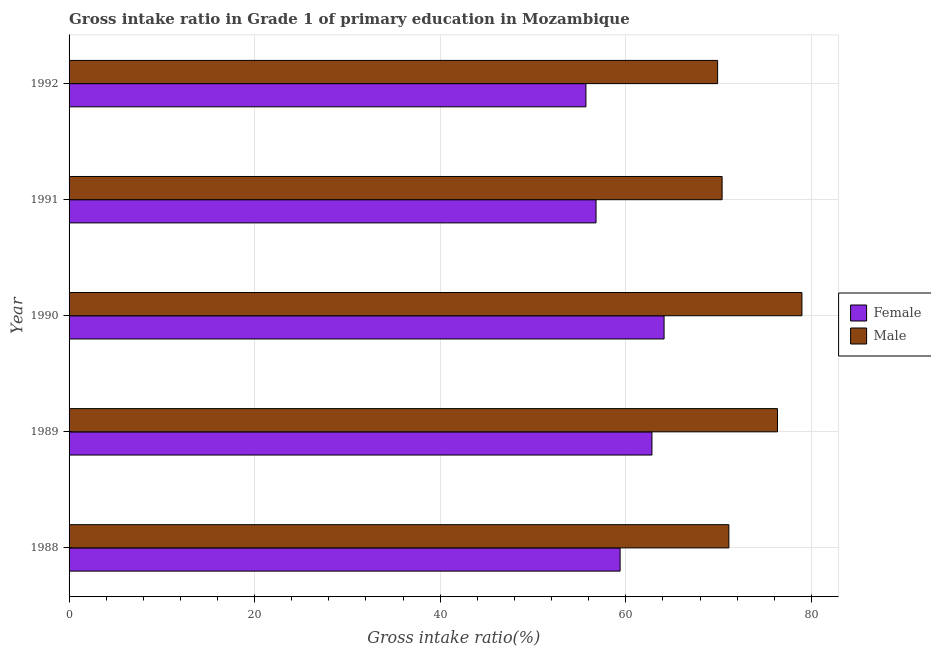How many different coloured bars are there?
Keep it short and to the point. 2. Are the number of bars per tick equal to the number of legend labels?
Ensure brevity in your answer.  Yes. How many bars are there on the 2nd tick from the top?
Provide a short and direct response. 2. What is the label of the 4th group of bars from the top?
Ensure brevity in your answer.  1989. In how many cases, is the number of bars for a given year not equal to the number of legend labels?
Make the answer very short. 0. What is the gross intake ratio(female) in 1989?
Ensure brevity in your answer.  62.82. Across all years, what is the maximum gross intake ratio(male)?
Keep it short and to the point. 78.98. Across all years, what is the minimum gross intake ratio(female)?
Give a very brief answer. 55.7. In which year was the gross intake ratio(male) maximum?
Give a very brief answer. 1990. What is the total gross intake ratio(female) in the graph?
Ensure brevity in your answer.  298.83. What is the difference between the gross intake ratio(female) in 1988 and that in 1990?
Keep it short and to the point. -4.74. What is the difference between the gross intake ratio(female) in 1989 and the gross intake ratio(male) in 1991?
Your answer should be very brief. -7.56. What is the average gross intake ratio(male) per year?
Make the answer very short. 73.34. In the year 1991, what is the difference between the gross intake ratio(male) and gross intake ratio(female)?
Offer a very short reply. 13.59. What is the ratio of the gross intake ratio(male) in 1990 to that in 1992?
Keep it short and to the point. 1.13. Is the gross intake ratio(male) in 1989 less than that in 1990?
Give a very brief answer. Yes. What is the difference between the highest and the second highest gross intake ratio(male)?
Your response must be concise. 2.63. What is the difference between the highest and the lowest gross intake ratio(male)?
Provide a short and direct response. 9.09. How many bars are there?
Your answer should be very brief. 10. Are all the bars in the graph horizontal?
Make the answer very short. Yes. What is the difference between two consecutive major ticks on the X-axis?
Your answer should be compact. 20. Are the values on the major ticks of X-axis written in scientific E-notation?
Make the answer very short. No. Does the graph contain any zero values?
Your answer should be compact. No. Does the graph contain grids?
Keep it short and to the point. Yes. How are the legend labels stacked?
Your response must be concise. Vertical. What is the title of the graph?
Your answer should be compact. Gross intake ratio in Grade 1 of primary education in Mozambique. Does "Private credit bureau" appear as one of the legend labels in the graph?
Your response must be concise. No. What is the label or title of the X-axis?
Give a very brief answer. Gross intake ratio(%). What is the label or title of the Y-axis?
Provide a short and direct response. Year. What is the Gross intake ratio(%) in Female in 1988?
Ensure brevity in your answer.  59.39. What is the Gross intake ratio(%) in Male in 1988?
Your answer should be compact. 71.11. What is the Gross intake ratio(%) of Female in 1989?
Provide a succinct answer. 62.82. What is the Gross intake ratio(%) of Male in 1989?
Give a very brief answer. 76.35. What is the Gross intake ratio(%) in Female in 1990?
Offer a terse response. 64.13. What is the Gross intake ratio(%) in Male in 1990?
Your answer should be compact. 78.98. What is the Gross intake ratio(%) of Female in 1991?
Ensure brevity in your answer.  56.79. What is the Gross intake ratio(%) in Male in 1991?
Keep it short and to the point. 70.38. What is the Gross intake ratio(%) in Female in 1992?
Provide a succinct answer. 55.7. What is the Gross intake ratio(%) in Male in 1992?
Your answer should be very brief. 69.9. Across all years, what is the maximum Gross intake ratio(%) of Female?
Your answer should be very brief. 64.13. Across all years, what is the maximum Gross intake ratio(%) in Male?
Offer a terse response. 78.98. Across all years, what is the minimum Gross intake ratio(%) in Female?
Your answer should be compact. 55.7. Across all years, what is the minimum Gross intake ratio(%) of Male?
Keep it short and to the point. 69.9. What is the total Gross intake ratio(%) of Female in the graph?
Your answer should be very brief. 298.83. What is the total Gross intake ratio(%) in Male in the graph?
Give a very brief answer. 366.72. What is the difference between the Gross intake ratio(%) in Female in 1988 and that in 1989?
Your answer should be very brief. -3.43. What is the difference between the Gross intake ratio(%) in Male in 1988 and that in 1989?
Keep it short and to the point. -5.24. What is the difference between the Gross intake ratio(%) in Female in 1988 and that in 1990?
Keep it short and to the point. -4.74. What is the difference between the Gross intake ratio(%) in Male in 1988 and that in 1990?
Keep it short and to the point. -7.88. What is the difference between the Gross intake ratio(%) of Female in 1988 and that in 1991?
Ensure brevity in your answer.  2.59. What is the difference between the Gross intake ratio(%) of Male in 1988 and that in 1991?
Make the answer very short. 0.73. What is the difference between the Gross intake ratio(%) in Female in 1988 and that in 1992?
Your answer should be compact. 3.68. What is the difference between the Gross intake ratio(%) in Male in 1988 and that in 1992?
Give a very brief answer. 1.21. What is the difference between the Gross intake ratio(%) of Female in 1989 and that in 1990?
Offer a very short reply. -1.31. What is the difference between the Gross intake ratio(%) in Male in 1989 and that in 1990?
Make the answer very short. -2.63. What is the difference between the Gross intake ratio(%) in Female in 1989 and that in 1991?
Provide a short and direct response. 6.03. What is the difference between the Gross intake ratio(%) of Male in 1989 and that in 1991?
Provide a short and direct response. 5.97. What is the difference between the Gross intake ratio(%) of Female in 1989 and that in 1992?
Ensure brevity in your answer.  7.12. What is the difference between the Gross intake ratio(%) in Male in 1989 and that in 1992?
Your answer should be compact. 6.45. What is the difference between the Gross intake ratio(%) of Female in 1990 and that in 1991?
Offer a terse response. 7.33. What is the difference between the Gross intake ratio(%) of Male in 1990 and that in 1991?
Keep it short and to the point. 8.6. What is the difference between the Gross intake ratio(%) of Female in 1990 and that in 1992?
Provide a succinct answer. 8.42. What is the difference between the Gross intake ratio(%) in Male in 1990 and that in 1992?
Your answer should be compact. 9.09. What is the difference between the Gross intake ratio(%) of Female in 1991 and that in 1992?
Your answer should be very brief. 1.09. What is the difference between the Gross intake ratio(%) in Male in 1991 and that in 1992?
Make the answer very short. 0.48. What is the difference between the Gross intake ratio(%) of Female in 1988 and the Gross intake ratio(%) of Male in 1989?
Make the answer very short. -16.96. What is the difference between the Gross intake ratio(%) in Female in 1988 and the Gross intake ratio(%) in Male in 1990?
Your answer should be compact. -19.6. What is the difference between the Gross intake ratio(%) of Female in 1988 and the Gross intake ratio(%) of Male in 1991?
Your answer should be compact. -10.99. What is the difference between the Gross intake ratio(%) in Female in 1988 and the Gross intake ratio(%) in Male in 1992?
Offer a very short reply. -10.51. What is the difference between the Gross intake ratio(%) in Female in 1989 and the Gross intake ratio(%) in Male in 1990?
Offer a terse response. -16.16. What is the difference between the Gross intake ratio(%) in Female in 1989 and the Gross intake ratio(%) in Male in 1991?
Your answer should be compact. -7.56. What is the difference between the Gross intake ratio(%) of Female in 1989 and the Gross intake ratio(%) of Male in 1992?
Provide a succinct answer. -7.08. What is the difference between the Gross intake ratio(%) in Female in 1990 and the Gross intake ratio(%) in Male in 1991?
Your response must be concise. -6.25. What is the difference between the Gross intake ratio(%) of Female in 1990 and the Gross intake ratio(%) of Male in 1992?
Make the answer very short. -5.77. What is the difference between the Gross intake ratio(%) in Female in 1991 and the Gross intake ratio(%) in Male in 1992?
Your answer should be compact. -13.1. What is the average Gross intake ratio(%) in Female per year?
Your answer should be very brief. 59.77. What is the average Gross intake ratio(%) of Male per year?
Make the answer very short. 73.34. In the year 1988, what is the difference between the Gross intake ratio(%) in Female and Gross intake ratio(%) in Male?
Give a very brief answer. -11.72. In the year 1989, what is the difference between the Gross intake ratio(%) in Female and Gross intake ratio(%) in Male?
Your response must be concise. -13.53. In the year 1990, what is the difference between the Gross intake ratio(%) of Female and Gross intake ratio(%) of Male?
Make the answer very short. -14.86. In the year 1991, what is the difference between the Gross intake ratio(%) in Female and Gross intake ratio(%) in Male?
Give a very brief answer. -13.59. In the year 1992, what is the difference between the Gross intake ratio(%) in Female and Gross intake ratio(%) in Male?
Offer a terse response. -14.19. What is the ratio of the Gross intake ratio(%) of Female in 1988 to that in 1989?
Your answer should be compact. 0.95. What is the ratio of the Gross intake ratio(%) in Male in 1988 to that in 1989?
Your response must be concise. 0.93. What is the ratio of the Gross intake ratio(%) of Female in 1988 to that in 1990?
Offer a very short reply. 0.93. What is the ratio of the Gross intake ratio(%) of Male in 1988 to that in 1990?
Your answer should be compact. 0.9. What is the ratio of the Gross intake ratio(%) in Female in 1988 to that in 1991?
Keep it short and to the point. 1.05. What is the ratio of the Gross intake ratio(%) of Male in 1988 to that in 1991?
Offer a very short reply. 1.01. What is the ratio of the Gross intake ratio(%) in Female in 1988 to that in 1992?
Your response must be concise. 1.07. What is the ratio of the Gross intake ratio(%) of Male in 1988 to that in 1992?
Keep it short and to the point. 1.02. What is the ratio of the Gross intake ratio(%) in Female in 1989 to that in 1990?
Your answer should be very brief. 0.98. What is the ratio of the Gross intake ratio(%) in Male in 1989 to that in 1990?
Ensure brevity in your answer.  0.97. What is the ratio of the Gross intake ratio(%) of Female in 1989 to that in 1991?
Offer a terse response. 1.11. What is the ratio of the Gross intake ratio(%) of Male in 1989 to that in 1991?
Offer a terse response. 1.08. What is the ratio of the Gross intake ratio(%) in Female in 1989 to that in 1992?
Ensure brevity in your answer.  1.13. What is the ratio of the Gross intake ratio(%) in Male in 1989 to that in 1992?
Your response must be concise. 1.09. What is the ratio of the Gross intake ratio(%) in Female in 1990 to that in 1991?
Your answer should be compact. 1.13. What is the ratio of the Gross intake ratio(%) in Male in 1990 to that in 1991?
Ensure brevity in your answer.  1.12. What is the ratio of the Gross intake ratio(%) in Female in 1990 to that in 1992?
Offer a terse response. 1.15. What is the ratio of the Gross intake ratio(%) in Male in 1990 to that in 1992?
Provide a succinct answer. 1.13. What is the ratio of the Gross intake ratio(%) of Female in 1991 to that in 1992?
Keep it short and to the point. 1.02. What is the ratio of the Gross intake ratio(%) of Male in 1991 to that in 1992?
Offer a very short reply. 1.01. What is the difference between the highest and the second highest Gross intake ratio(%) in Female?
Ensure brevity in your answer.  1.31. What is the difference between the highest and the second highest Gross intake ratio(%) in Male?
Your response must be concise. 2.63. What is the difference between the highest and the lowest Gross intake ratio(%) of Female?
Offer a very short reply. 8.42. What is the difference between the highest and the lowest Gross intake ratio(%) in Male?
Give a very brief answer. 9.09. 